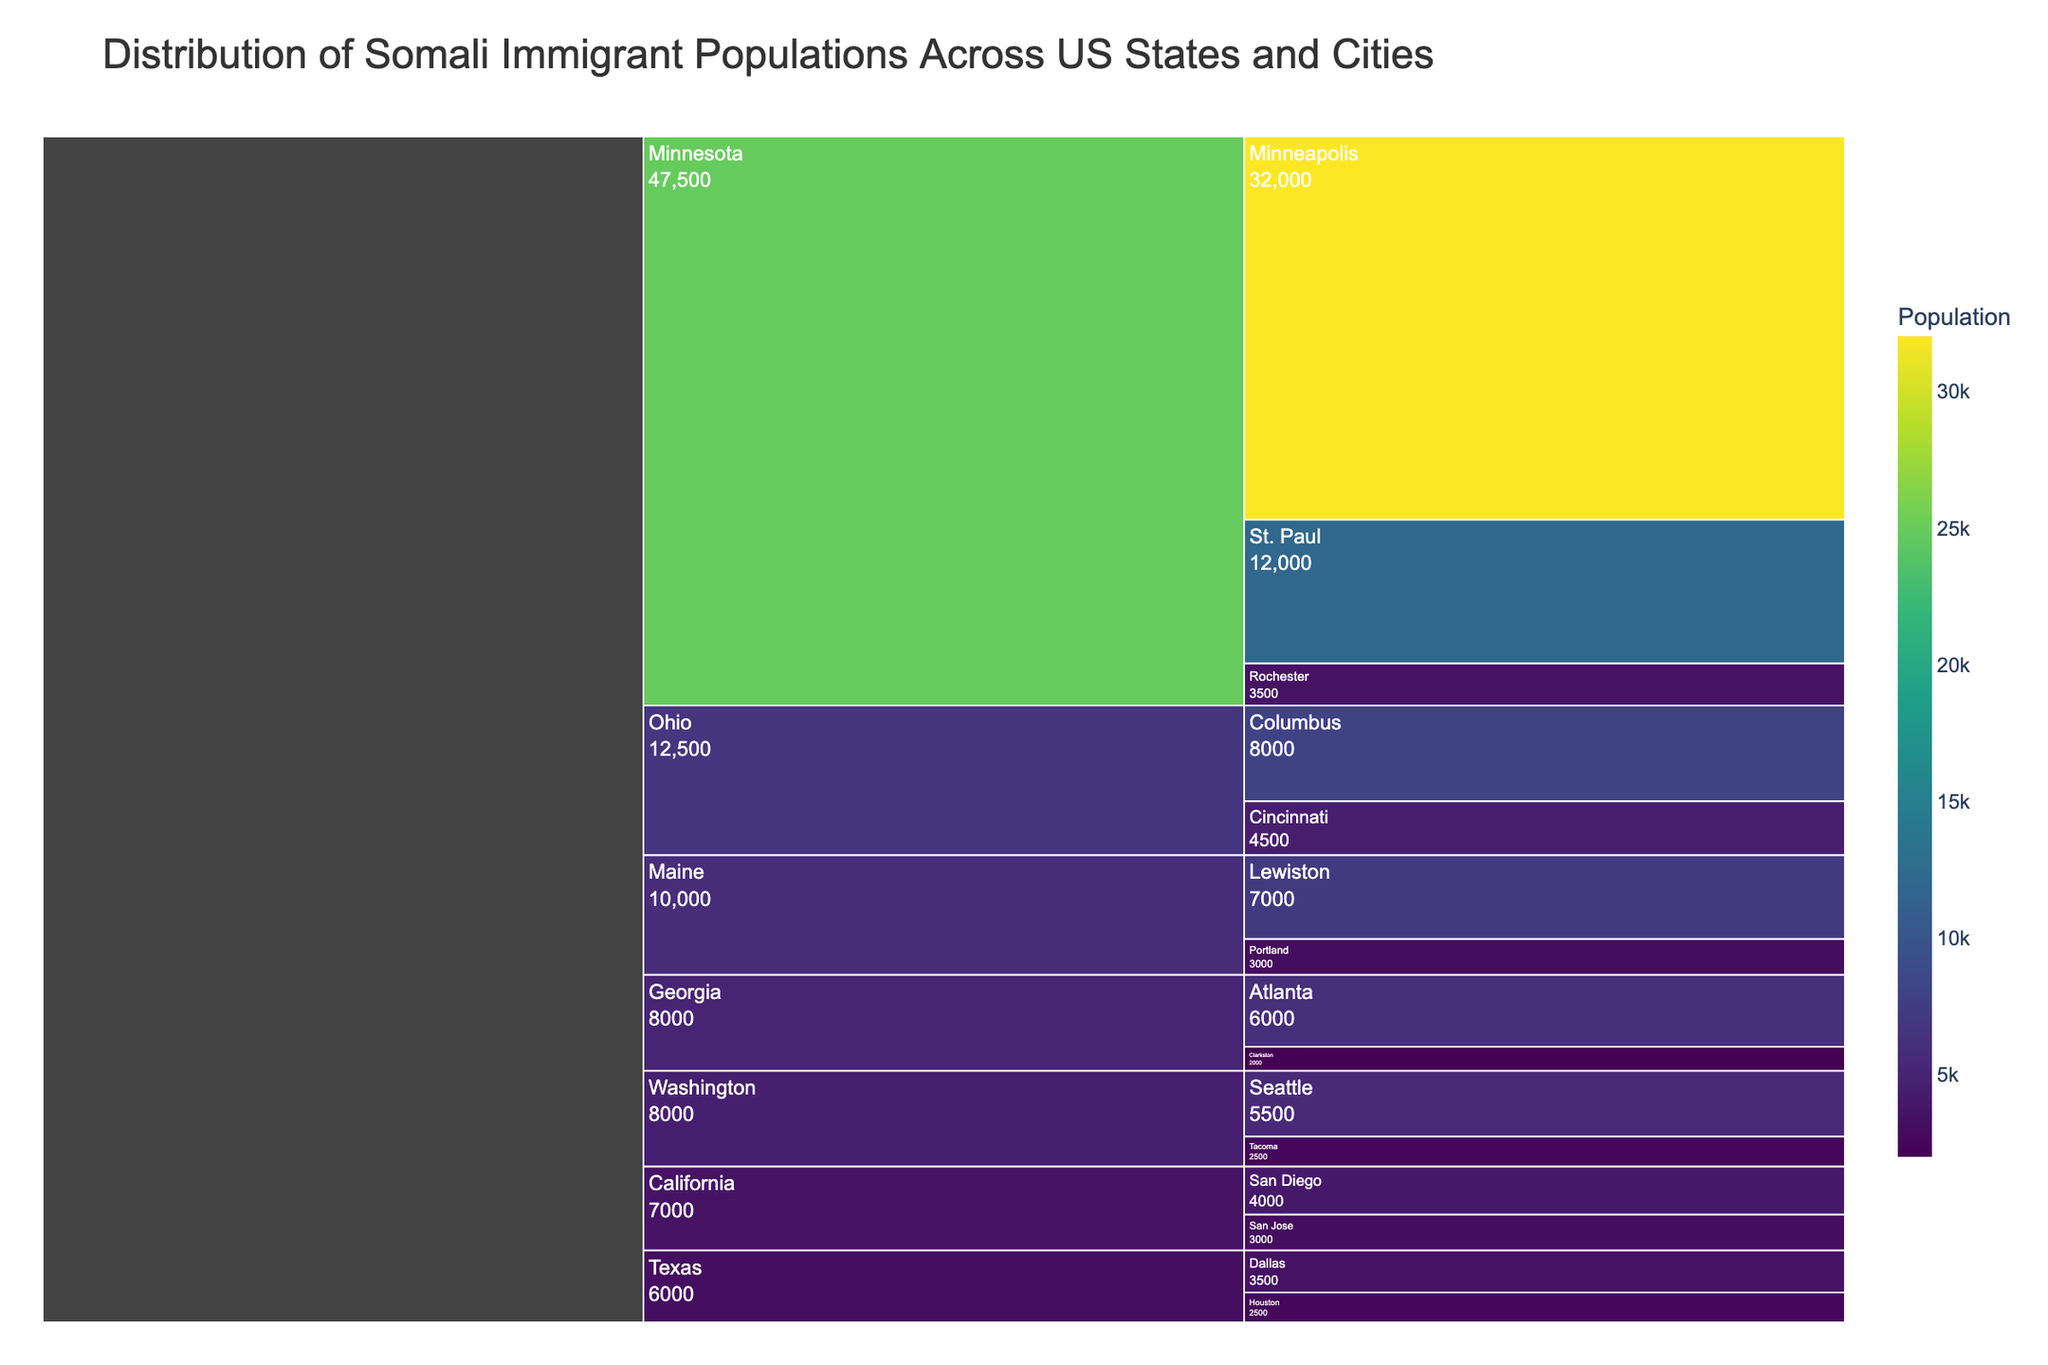What's the title of the icicle chart? The title is always placed at the top of the chart. Look at the centered large text.
Answer: Distribution of Somali Immigrant Populations Across US States and Cities Which city in Minnesota has the highest Somali immigrant population? Identify the cities listed under Minnesota and compare their population values.
Answer: Minneapolis What is the total Somali immigrant population in Ohio? Add the population numbers for Columbus and Cincinnati (8000 + 4500).
Answer: 12500 How does the Somali immigrant population of Atlanta compare to that of Seattle? Compare the values of the two cities directly. Atlanta has 6000, and Seattle has 5500, so Atlanta's is higher.
Answer: Atlanta has a higher population Which state has the largest sum of Somali immigrant populations? Sum the populations of all cities in each state and compare the totals.
Answer: Minnesota What is the difference in Somali immigrant population between St. Paul and San Diego? Subtract the population of San Diego from that of St. Paul (12000 - 4000).
Answer: 8000 What color represents the highest population values in this icicle chart? Examine the color scale (Viridis) where higher population values are usually depicted in brighter or more intense colors.
Answer: Brighter, more intense colors How many cities in total are represented in the chart? Count each city listed under all states.
Answer: 14 What is the average Somali immigrant population across all the cities in Texas? Add populations in Dallas and Houston, then divide by the number of cities (3500 + 2500) / 2.
Answer: 3000 Which city has the smallest Somali immigrant population in the chart? Identify the city with the lowest population value by looking through the list.
Answer: Clarkston 